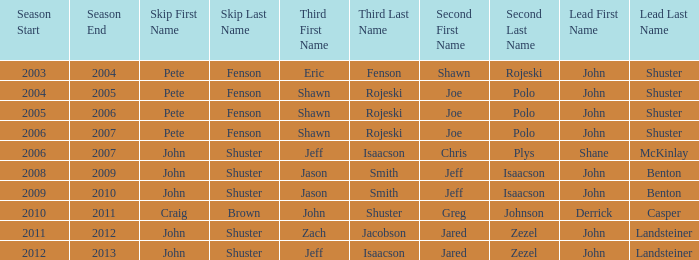Who was the lead with Pete Fenson as skip and Joe Polo as second in season 2005–06? John Shuster. 